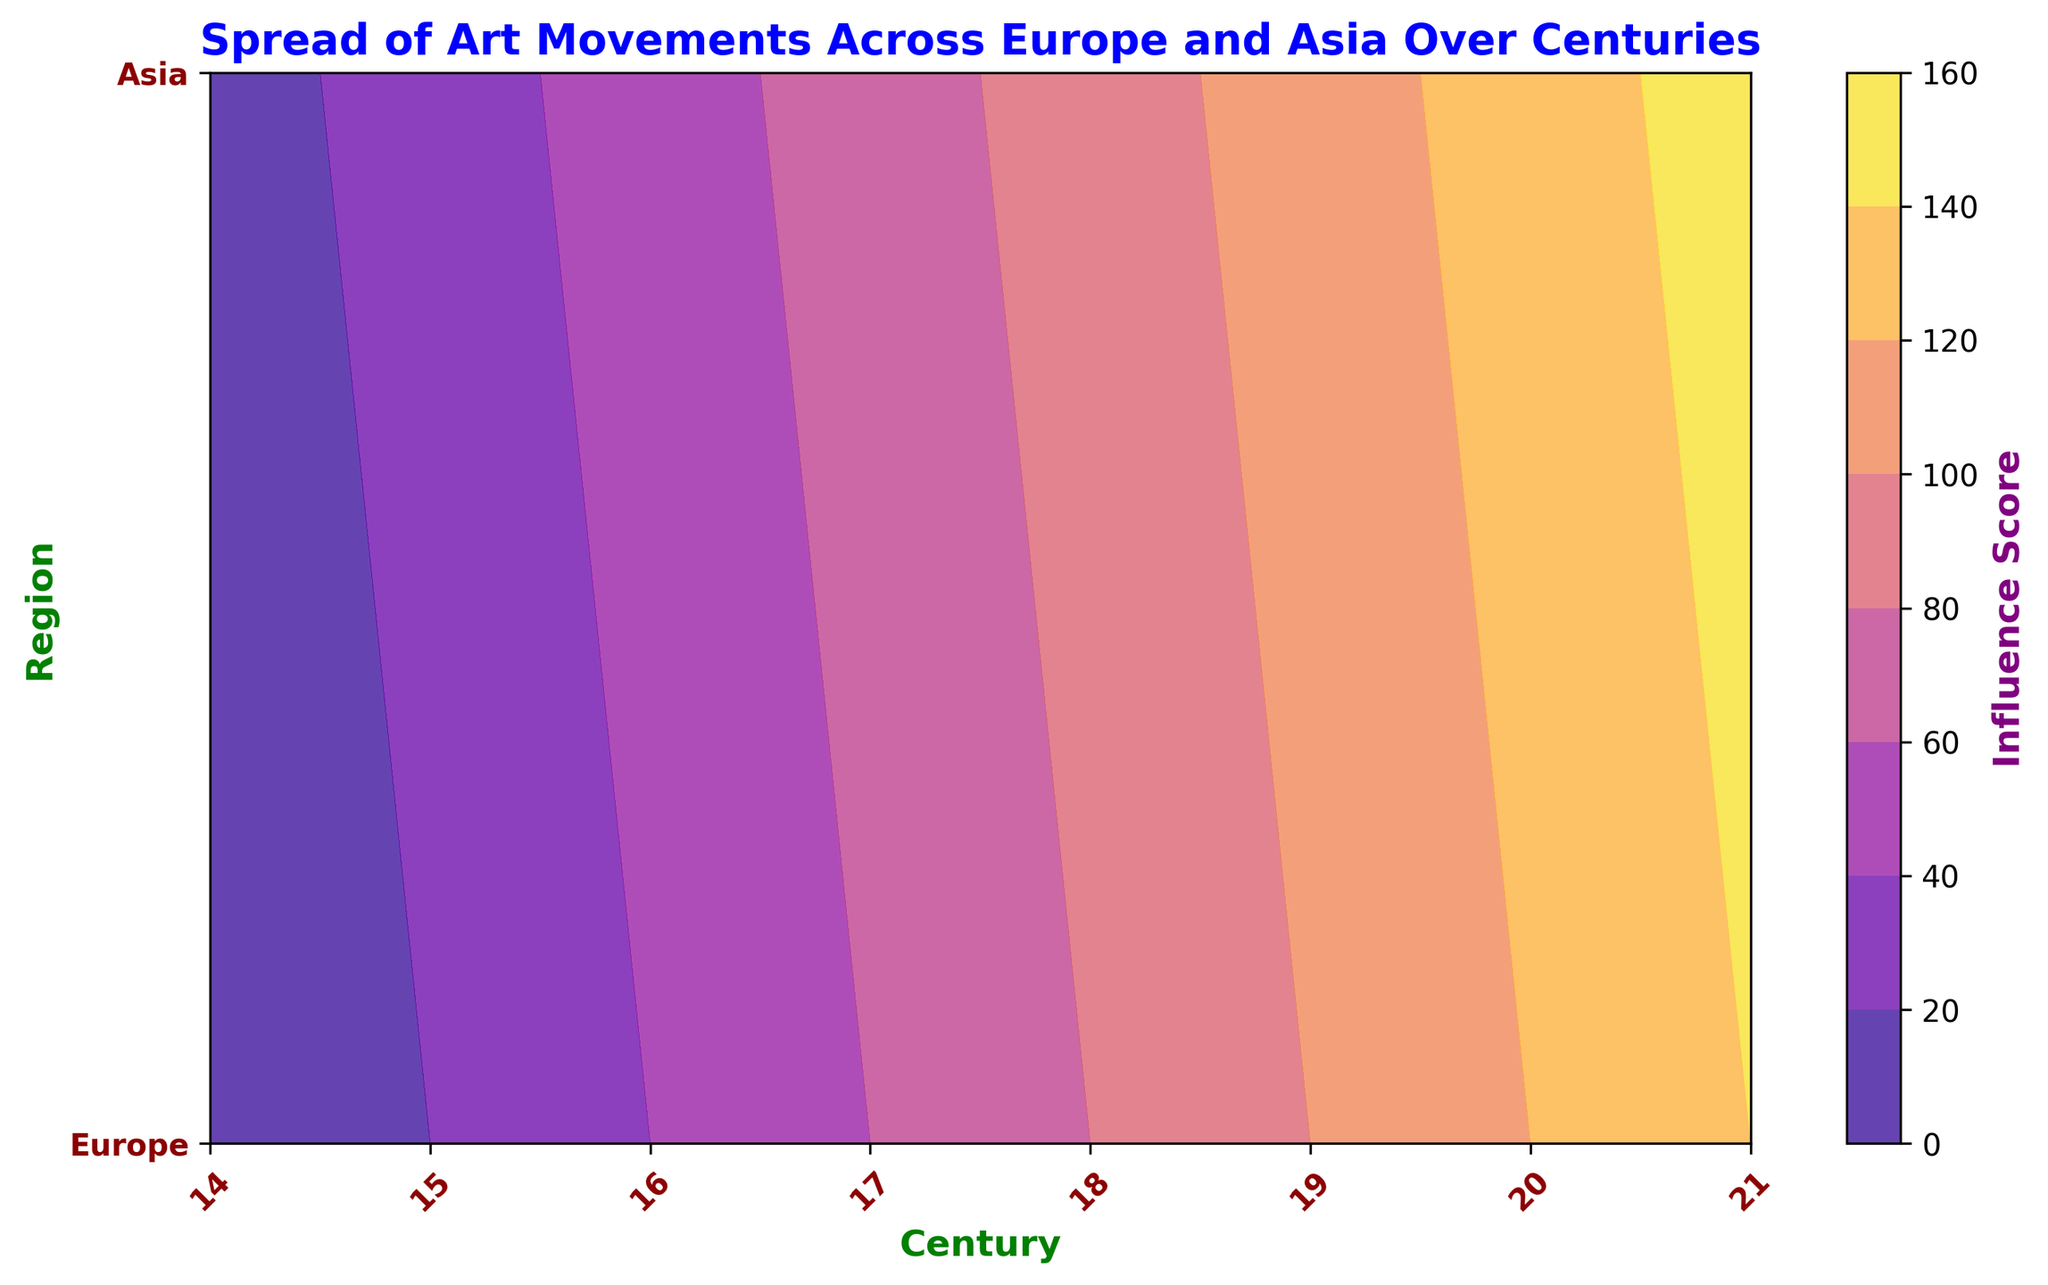Which century shows the highest influence score for Asia? Looking at the Asia region, the highest point on the contour plot occurs at the 21st century. The influence score for Asia in the 21st century is 150, which is the highest.
Answer: 21st century How do the influence scores in the 18th century compare between Europe and Asia? Checking the 18th century on the X-axis and comparing the values for Europe and Asia, Europe has an influence score of 80 and Asia has a score of 90. Therefore, Asia's influence score is higher than Europe's in the 18th century.
Answer: Asia's score is higher Considering the 15th and 19th centuries in Europe, what is the difference in influence scores between these centuries? In the 15th century, Europe's influence score is 20, and in the 19th century, it is 100. The difference is 100 - 20 = 80.
Answer: 80 Which region had a higher influence score in the 16th century—the one with a lower plot color intensity? The contour colors indicate that Europe and Asia have different influence scores. In the 16th century, Europe has a score of 40 and Asia has a score of 50. Hence, Europe has a lower score and a lower color intensity.
Answer: Europe What is the overall trend in influence scores for Europe from the 14th to the 21st century? Observing the influence scores over the centuries, Europe starts with a score of 0 in the 14th century and increases gradually to 140 by the 21st century. This indicates a consistent upward trend in influence scores over time.
Answer: Upward trend By how much does the influence score increase from the 19th to 20th century in Europe? Checking the influence scores: in the 19th century, Europe has a score of 100; in the 20th century, it rises to 120. The increase is 120 - 100 = 20.
Answer: 20 What is the gradient of color change from the 14th to the 17th century for Europe compared to Asia? The colors on the contour plot for Europe transition from very light in the 14th century to darker by the 17th century, corresponding to a score increase from 0 to 60. In Asia, the colors also darken, with scores rising from 10 to 70 from the 14th to 17th century. The gradient in both regions shows a similar pattern of increasing influence but Asia's starts already higher.
Answer: Similar gradient, Asia starts higher Which century had a steeper increase in influence for Asia: the 14th to 15th or the 20th to 21st? From the 14th to the 15th century in Asia, the influence score increases from 10 to 30, a difference of 20. From the 20th to the 21st century, it increases from 130 to 150, also a difference of 20. Both periods show the same increment of 20 in influence score.
Answer: Same increase How does the influence score trend for Asia compare to Europe's trend over all centuries? Both regions show an increasing trend in influence scores over time. Starting from lower influence in the 14th century to reaching high influence scores by the 21st century. Europe's trend is from 0 to 140, and Asia's is from 10 to 150. Thus both regions exhibit a parallel increase, with Asia consistently higher.
Answer: Parallel increase, Asia consistently higher 